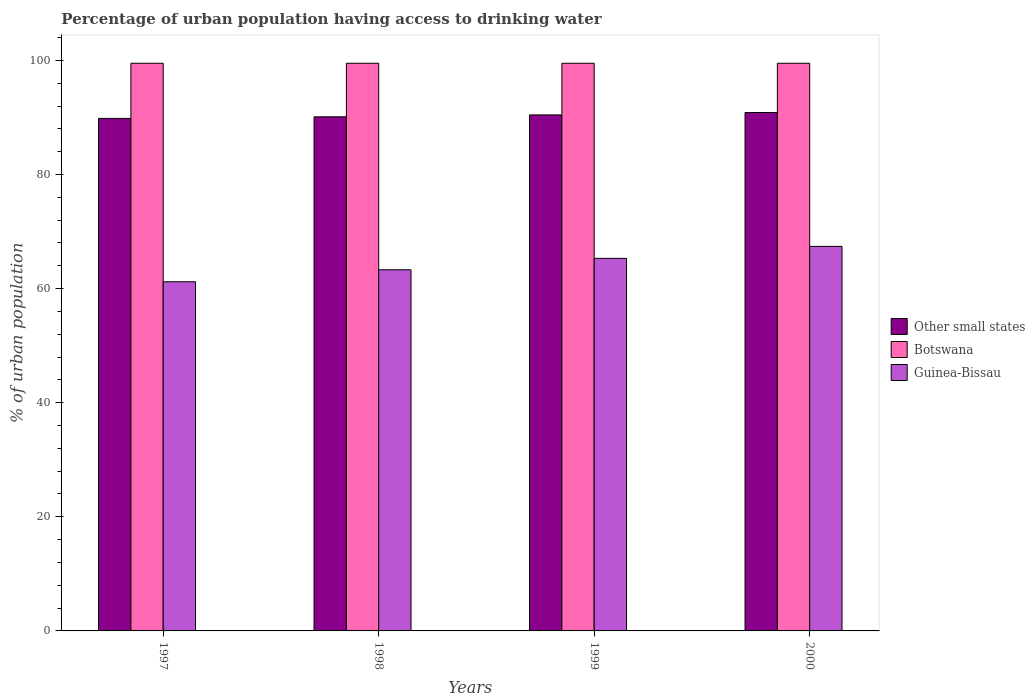How many different coloured bars are there?
Give a very brief answer. 3. Are the number of bars per tick equal to the number of legend labels?
Provide a succinct answer. Yes. Are the number of bars on each tick of the X-axis equal?
Make the answer very short. Yes. What is the label of the 3rd group of bars from the left?
Offer a very short reply. 1999. In how many cases, is the number of bars for a given year not equal to the number of legend labels?
Your answer should be compact. 0. What is the percentage of urban population having access to drinking water in Other small states in 1999?
Provide a short and direct response. 90.45. Across all years, what is the maximum percentage of urban population having access to drinking water in Other small states?
Offer a very short reply. 90.87. Across all years, what is the minimum percentage of urban population having access to drinking water in Botswana?
Your answer should be very brief. 99.5. In which year was the percentage of urban population having access to drinking water in Botswana maximum?
Ensure brevity in your answer.  1997. What is the total percentage of urban population having access to drinking water in Other small states in the graph?
Give a very brief answer. 361.25. What is the difference between the percentage of urban population having access to drinking water in Other small states in 1998 and that in 1999?
Keep it short and to the point. -0.33. What is the difference between the percentage of urban population having access to drinking water in Other small states in 1998 and the percentage of urban population having access to drinking water in Guinea-Bissau in 1997?
Offer a terse response. 28.91. What is the average percentage of urban population having access to drinking water in Other small states per year?
Make the answer very short. 90.31. In the year 1997, what is the difference between the percentage of urban population having access to drinking water in Guinea-Bissau and percentage of urban population having access to drinking water in Botswana?
Make the answer very short. -38.3. In how many years, is the percentage of urban population having access to drinking water in Other small states greater than 100 %?
Your answer should be very brief. 0. What is the ratio of the percentage of urban population having access to drinking water in Guinea-Bissau in 1997 to that in 1999?
Provide a succinct answer. 0.94. Is the percentage of urban population having access to drinking water in Guinea-Bissau in 1997 less than that in 2000?
Your answer should be compact. Yes. Is the difference between the percentage of urban population having access to drinking water in Guinea-Bissau in 1997 and 1998 greater than the difference between the percentage of urban population having access to drinking water in Botswana in 1997 and 1998?
Make the answer very short. No. What is the difference between the highest and the second highest percentage of urban population having access to drinking water in Other small states?
Provide a succinct answer. 0.42. What is the difference between the highest and the lowest percentage of urban population having access to drinking water in Botswana?
Make the answer very short. 0. What does the 3rd bar from the left in 1999 represents?
Provide a succinct answer. Guinea-Bissau. What does the 1st bar from the right in 1997 represents?
Give a very brief answer. Guinea-Bissau. What is the difference between two consecutive major ticks on the Y-axis?
Offer a terse response. 20. Are the values on the major ticks of Y-axis written in scientific E-notation?
Your answer should be very brief. No. Does the graph contain any zero values?
Make the answer very short. No. Does the graph contain grids?
Provide a short and direct response. No. Where does the legend appear in the graph?
Keep it short and to the point. Center right. How many legend labels are there?
Offer a very short reply. 3. What is the title of the graph?
Offer a terse response. Percentage of urban population having access to drinking water. What is the label or title of the X-axis?
Give a very brief answer. Years. What is the label or title of the Y-axis?
Ensure brevity in your answer.  % of urban population. What is the % of urban population of Other small states in 1997?
Keep it short and to the point. 89.83. What is the % of urban population in Botswana in 1997?
Make the answer very short. 99.5. What is the % of urban population in Guinea-Bissau in 1997?
Your response must be concise. 61.2. What is the % of urban population of Other small states in 1998?
Provide a short and direct response. 90.11. What is the % of urban population of Botswana in 1998?
Give a very brief answer. 99.5. What is the % of urban population in Guinea-Bissau in 1998?
Your answer should be very brief. 63.3. What is the % of urban population of Other small states in 1999?
Offer a very short reply. 90.45. What is the % of urban population in Botswana in 1999?
Ensure brevity in your answer.  99.5. What is the % of urban population of Guinea-Bissau in 1999?
Your response must be concise. 65.3. What is the % of urban population of Other small states in 2000?
Offer a very short reply. 90.87. What is the % of urban population in Botswana in 2000?
Give a very brief answer. 99.5. What is the % of urban population in Guinea-Bissau in 2000?
Make the answer very short. 67.4. Across all years, what is the maximum % of urban population of Other small states?
Your response must be concise. 90.87. Across all years, what is the maximum % of urban population of Botswana?
Offer a terse response. 99.5. Across all years, what is the maximum % of urban population in Guinea-Bissau?
Provide a short and direct response. 67.4. Across all years, what is the minimum % of urban population of Other small states?
Provide a short and direct response. 89.83. Across all years, what is the minimum % of urban population in Botswana?
Your response must be concise. 99.5. Across all years, what is the minimum % of urban population in Guinea-Bissau?
Keep it short and to the point. 61.2. What is the total % of urban population in Other small states in the graph?
Make the answer very short. 361.25. What is the total % of urban population of Botswana in the graph?
Give a very brief answer. 398. What is the total % of urban population of Guinea-Bissau in the graph?
Provide a short and direct response. 257.2. What is the difference between the % of urban population in Other small states in 1997 and that in 1998?
Provide a short and direct response. -0.28. What is the difference between the % of urban population in Botswana in 1997 and that in 1998?
Keep it short and to the point. 0. What is the difference between the % of urban population of Other small states in 1997 and that in 1999?
Make the answer very short. -0.62. What is the difference between the % of urban population of Botswana in 1997 and that in 1999?
Your answer should be very brief. 0. What is the difference between the % of urban population in Guinea-Bissau in 1997 and that in 1999?
Give a very brief answer. -4.1. What is the difference between the % of urban population of Other small states in 1997 and that in 2000?
Provide a succinct answer. -1.04. What is the difference between the % of urban population of Guinea-Bissau in 1997 and that in 2000?
Make the answer very short. -6.2. What is the difference between the % of urban population in Other small states in 1998 and that in 1999?
Offer a very short reply. -0.33. What is the difference between the % of urban population of Botswana in 1998 and that in 1999?
Provide a short and direct response. 0. What is the difference between the % of urban population in Guinea-Bissau in 1998 and that in 1999?
Make the answer very short. -2. What is the difference between the % of urban population of Other small states in 1998 and that in 2000?
Make the answer very short. -0.75. What is the difference between the % of urban population in Botswana in 1998 and that in 2000?
Your response must be concise. 0. What is the difference between the % of urban population in Other small states in 1999 and that in 2000?
Keep it short and to the point. -0.42. What is the difference between the % of urban population in Guinea-Bissau in 1999 and that in 2000?
Make the answer very short. -2.1. What is the difference between the % of urban population of Other small states in 1997 and the % of urban population of Botswana in 1998?
Give a very brief answer. -9.67. What is the difference between the % of urban population in Other small states in 1997 and the % of urban population in Guinea-Bissau in 1998?
Keep it short and to the point. 26.53. What is the difference between the % of urban population of Botswana in 1997 and the % of urban population of Guinea-Bissau in 1998?
Offer a very short reply. 36.2. What is the difference between the % of urban population in Other small states in 1997 and the % of urban population in Botswana in 1999?
Make the answer very short. -9.67. What is the difference between the % of urban population in Other small states in 1997 and the % of urban population in Guinea-Bissau in 1999?
Your answer should be very brief. 24.53. What is the difference between the % of urban population in Botswana in 1997 and the % of urban population in Guinea-Bissau in 1999?
Offer a very short reply. 34.2. What is the difference between the % of urban population of Other small states in 1997 and the % of urban population of Botswana in 2000?
Offer a terse response. -9.67. What is the difference between the % of urban population of Other small states in 1997 and the % of urban population of Guinea-Bissau in 2000?
Your response must be concise. 22.43. What is the difference between the % of urban population in Botswana in 1997 and the % of urban population in Guinea-Bissau in 2000?
Keep it short and to the point. 32.1. What is the difference between the % of urban population in Other small states in 1998 and the % of urban population in Botswana in 1999?
Keep it short and to the point. -9.39. What is the difference between the % of urban population of Other small states in 1998 and the % of urban population of Guinea-Bissau in 1999?
Provide a succinct answer. 24.81. What is the difference between the % of urban population of Botswana in 1998 and the % of urban population of Guinea-Bissau in 1999?
Your answer should be compact. 34.2. What is the difference between the % of urban population of Other small states in 1998 and the % of urban population of Botswana in 2000?
Offer a very short reply. -9.39. What is the difference between the % of urban population of Other small states in 1998 and the % of urban population of Guinea-Bissau in 2000?
Provide a short and direct response. 22.71. What is the difference between the % of urban population in Botswana in 1998 and the % of urban population in Guinea-Bissau in 2000?
Give a very brief answer. 32.1. What is the difference between the % of urban population of Other small states in 1999 and the % of urban population of Botswana in 2000?
Keep it short and to the point. -9.05. What is the difference between the % of urban population of Other small states in 1999 and the % of urban population of Guinea-Bissau in 2000?
Give a very brief answer. 23.05. What is the difference between the % of urban population in Botswana in 1999 and the % of urban population in Guinea-Bissau in 2000?
Your answer should be very brief. 32.1. What is the average % of urban population of Other small states per year?
Offer a very short reply. 90.31. What is the average % of urban population in Botswana per year?
Your answer should be compact. 99.5. What is the average % of urban population of Guinea-Bissau per year?
Offer a very short reply. 64.3. In the year 1997, what is the difference between the % of urban population in Other small states and % of urban population in Botswana?
Provide a short and direct response. -9.67. In the year 1997, what is the difference between the % of urban population in Other small states and % of urban population in Guinea-Bissau?
Ensure brevity in your answer.  28.63. In the year 1997, what is the difference between the % of urban population in Botswana and % of urban population in Guinea-Bissau?
Provide a short and direct response. 38.3. In the year 1998, what is the difference between the % of urban population of Other small states and % of urban population of Botswana?
Ensure brevity in your answer.  -9.39. In the year 1998, what is the difference between the % of urban population in Other small states and % of urban population in Guinea-Bissau?
Offer a terse response. 26.81. In the year 1998, what is the difference between the % of urban population of Botswana and % of urban population of Guinea-Bissau?
Give a very brief answer. 36.2. In the year 1999, what is the difference between the % of urban population in Other small states and % of urban population in Botswana?
Keep it short and to the point. -9.05. In the year 1999, what is the difference between the % of urban population of Other small states and % of urban population of Guinea-Bissau?
Ensure brevity in your answer.  25.15. In the year 1999, what is the difference between the % of urban population of Botswana and % of urban population of Guinea-Bissau?
Your response must be concise. 34.2. In the year 2000, what is the difference between the % of urban population in Other small states and % of urban population in Botswana?
Your response must be concise. -8.63. In the year 2000, what is the difference between the % of urban population in Other small states and % of urban population in Guinea-Bissau?
Give a very brief answer. 23.47. In the year 2000, what is the difference between the % of urban population in Botswana and % of urban population in Guinea-Bissau?
Offer a very short reply. 32.1. What is the ratio of the % of urban population of Guinea-Bissau in 1997 to that in 1998?
Keep it short and to the point. 0.97. What is the ratio of the % of urban population of Guinea-Bissau in 1997 to that in 1999?
Your answer should be very brief. 0.94. What is the ratio of the % of urban population in Botswana in 1997 to that in 2000?
Your response must be concise. 1. What is the ratio of the % of urban population of Guinea-Bissau in 1997 to that in 2000?
Your answer should be very brief. 0.91. What is the ratio of the % of urban population of Other small states in 1998 to that in 1999?
Your answer should be very brief. 1. What is the ratio of the % of urban population in Guinea-Bissau in 1998 to that in 1999?
Ensure brevity in your answer.  0.97. What is the ratio of the % of urban population in Other small states in 1998 to that in 2000?
Make the answer very short. 0.99. What is the ratio of the % of urban population of Guinea-Bissau in 1998 to that in 2000?
Your answer should be compact. 0.94. What is the ratio of the % of urban population in Other small states in 1999 to that in 2000?
Your response must be concise. 1. What is the ratio of the % of urban population in Guinea-Bissau in 1999 to that in 2000?
Ensure brevity in your answer.  0.97. What is the difference between the highest and the second highest % of urban population in Other small states?
Keep it short and to the point. 0.42. What is the difference between the highest and the second highest % of urban population of Botswana?
Give a very brief answer. 0. What is the difference between the highest and the lowest % of urban population of Other small states?
Keep it short and to the point. 1.04. What is the difference between the highest and the lowest % of urban population in Botswana?
Your response must be concise. 0. 